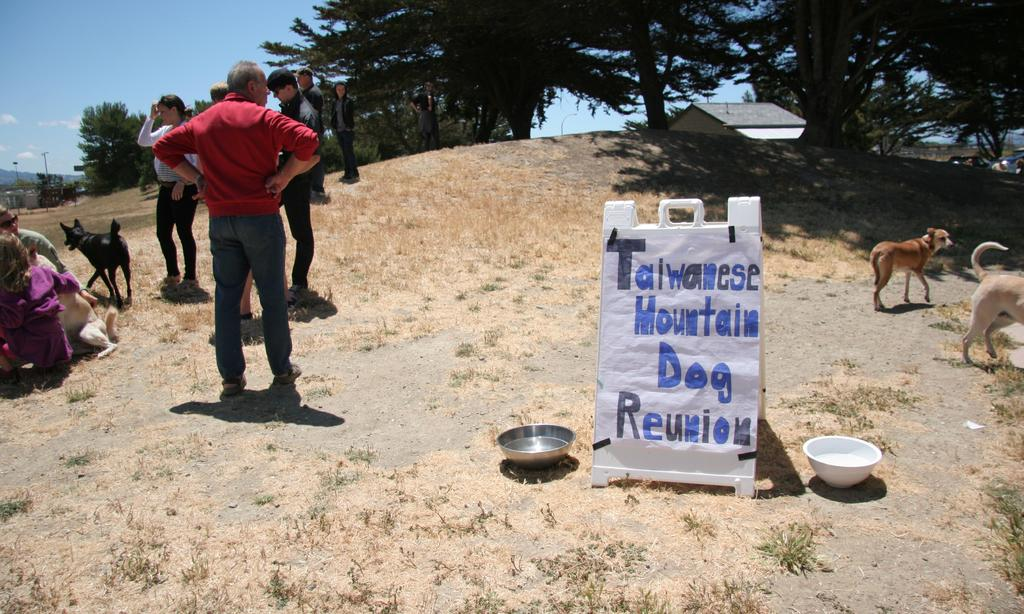How many people are in the image? There are persons standing in the image. What type of animal is present in the image? There is a dog in the image. What type of vegetation can be seen in the image? There are trees in the image. How many bowls are visible in the image? There are two bowls in the image. What is visible in the background of the image? The sky is visible in the image. What type of pleasure can be seen enjoying the scale in the image? There is no pleasure or scale present in the image; it features persons, a dog, trees, bowls, and the sky. How does the stop affect the persons and the dog in the image? There is no stop present in the image, so it cannot affect the persons or the dog. 